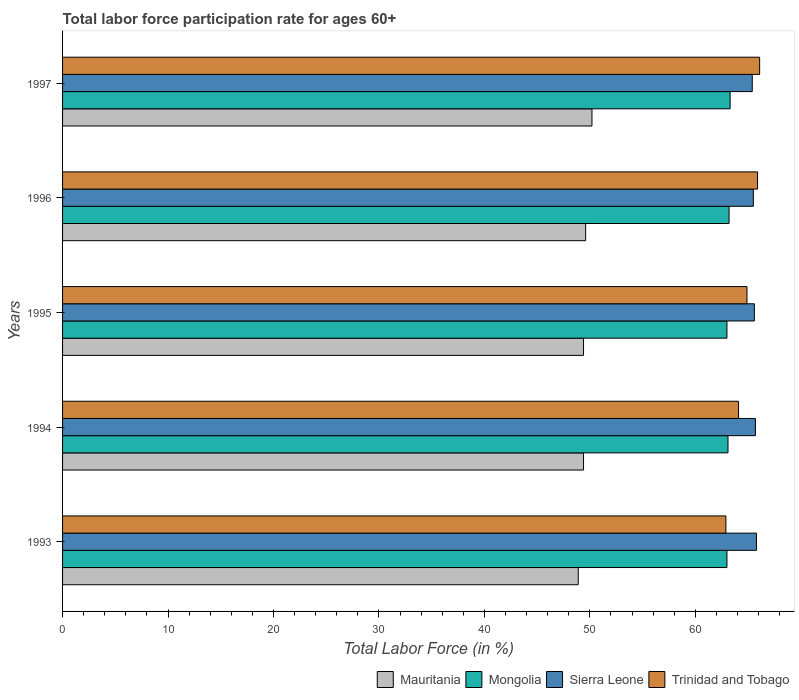How many different coloured bars are there?
Provide a succinct answer. 4. How many groups of bars are there?
Offer a terse response. 5. How many bars are there on the 1st tick from the top?
Provide a succinct answer. 4. How many bars are there on the 5th tick from the bottom?
Provide a succinct answer. 4. What is the label of the 2nd group of bars from the top?
Ensure brevity in your answer.  1996. What is the labor force participation rate in Mongolia in 1994?
Provide a short and direct response. 63.1. Across all years, what is the maximum labor force participation rate in Sierra Leone?
Give a very brief answer. 65.8. Across all years, what is the minimum labor force participation rate in Trinidad and Tobago?
Provide a short and direct response. 62.9. What is the total labor force participation rate in Mauritania in the graph?
Make the answer very short. 247.5. What is the difference between the labor force participation rate in Mauritania in 1993 and that in 1994?
Keep it short and to the point. -0.5. What is the difference between the labor force participation rate in Mongolia in 1994 and the labor force participation rate in Mauritania in 1993?
Provide a short and direct response. 14.2. What is the average labor force participation rate in Mauritania per year?
Offer a terse response. 49.5. In the year 1993, what is the difference between the labor force participation rate in Mongolia and labor force participation rate in Sierra Leone?
Make the answer very short. -2.8. In how many years, is the labor force participation rate in Sierra Leone greater than 20 %?
Keep it short and to the point. 5. What is the ratio of the labor force participation rate in Trinidad and Tobago in 1994 to that in 1997?
Offer a terse response. 0.97. Is the labor force participation rate in Mongolia in 1993 less than that in 1996?
Offer a very short reply. Yes. What is the difference between the highest and the second highest labor force participation rate in Trinidad and Tobago?
Keep it short and to the point. 0.2. What is the difference between the highest and the lowest labor force participation rate in Trinidad and Tobago?
Provide a short and direct response. 3.2. What does the 2nd bar from the top in 1997 represents?
Keep it short and to the point. Sierra Leone. What does the 2nd bar from the bottom in 1994 represents?
Provide a succinct answer. Mongolia. Are all the bars in the graph horizontal?
Make the answer very short. Yes. What is the difference between two consecutive major ticks on the X-axis?
Keep it short and to the point. 10. Are the values on the major ticks of X-axis written in scientific E-notation?
Give a very brief answer. No. Does the graph contain any zero values?
Your answer should be compact. No. What is the title of the graph?
Provide a succinct answer. Total labor force participation rate for ages 60+. What is the label or title of the X-axis?
Your response must be concise. Total Labor Force (in %). What is the Total Labor Force (in %) of Mauritania in 1993?
Offer a very short reply. 48.9. What is the Total Labor Force (in %) of Mongolia in 1993?
Your response must be concise. 63. What is the Total Labor Force (in %) of Sierra Leone in 1993?
Offer a terse response. 65.8. What is the Total Labor Force (in %) of Trinidad and Tobago in 1993?
Give a very brief answer. 62.9. What is the Total Labor Force (in %) of Mauritania in 1994?
Ensure brevity in your answer.  49.4. What is the Total Labor Force (in %) in Mongolia in 1994?
Offer a very short reply. 63.1. What is the Total Labor Force (in %) in Sierra Leone in 1994?
Ensure brevity in your answer.  65.7. What is the Total Labor Force (in %) of Trinidad and Tobago in 1994?
Provide a short and direct response. 64.1. What is the Total Labor Force (in %) of Mauritania in 1995?
Your answer should be compact. 49.4. What is the Total Labor Force (in %) of Mongolia in 1995?
Offer a terse response. 63. What is the Total Labor Force (in %) in Sierra Leone in 1995?
Provide a succinct answer. 65.6. What is the Total Labor Force (in %) of Trinidad and Tobago in 1995?
Make the answer very short. 64.9. What is the Total Labor Force (in %) of Mauritania in 1996?
Provide a short and direct response. 49.6. What is the Total Labor Force (in %) in Mongolia in 1996?
Make the answer very short. 63.2. What is the Total Labor Force (in %) in Sierra Leone in 1996?
Ensure brevity in your answer.  65.5. What is the Total Labor Force (in %) of Trinidad and Tobago in 1996?
Your response must be concise. 65.9. What is the Total Labor Force (in %) in Mauritania in 1997?
Keep it short and to the point. 50.2. What is the Total Labor Force (in %) in Mongolia in 1997?
Offer a very short reply. 63.3. What is the Total Labor Force (in %) of Sierra Leone in 1997?
Make the answer very short. 65.4. What is the Total Labor Force (in %) of Trinidad and Tobago in 1997?
Ensure brevity in your answer.  66.1. Across all years, what is the maximum Total Labor Force (in %) in Mauritania?
Offer a terse response. 50.2. Across all years, what is the maximum Total Labor Force (in %) in Mongolia?
Your answer should be very brief. 63.3. Across all years, what is the maximum Total Labor Force (in %) in Sierra Leone?
Your answer should be very brief. 65.8. Across all years, what is the maximum Total Labor Force (in %) in Trinidad and Tobago?
Make the answer very short. 66.1. Across all years, what is the minimum Total Labor Force (in %) of Mauritania?
Your answer should be very brief. 48.9. Across all years, what is the minimum Total Labor Force (in %) of Mongolia?
Keep it short and to the point. 63. Across all years, what is the minimum Total Labor Force (in %) in Sierra Leone?
Your answer should be very brief. 65.4. Across all years, what is the minimum Total Labor Force (in %) in Trinidad and Tobago?
Give a very brief answer. 62.9. What is the total Total Labor Force (in %) of Mauritania in the graph?
Your answer should be very brief. 247.5. What is the total Total Labor Force (in %) in Mongolia in the graph?
Provide a succinct answer. 315.6. What is the total Total Labor Force (in %) of Sierra Leone in the graph?
Your answer should be very brief. 328. What is the total Total Labor Force (in %) of Trinidad and Tobago in the graph?
Offer a terse response. 323.9. What is the difference between the Total Labor Force (in %) in Mauritania in 1993 and that in 1994?
Give a very brief answer. -0.5. What is the difference between the Total Labor Force (in %) in Trinidad and Tobago in 1993 and that in 1994?
Offer a very short reply. -1.2. What is the difference between the Total Labor Force (in %) of Mauritania in 1993 and that in 1995?
Provide a short and direct response. -0.5. What is the difference between the Total Labor Force (in %) in Mongolia in 1993 and that in 1995?
Ensure brevity in your answer.  0. What is the difference between the Total Labor Force (in %) in Sierra Leone in 1993 and that in 1995?
Give a very brief answer. 0.2. What is the difference between the Total Labor Force (in %) of Trinidad and Tobago in 1993 and that in 1995?
Your answer should be very brief. -2. What is the difference between the Total Labor Force (in %) in Mauritania in 1993 and that in 1996?
Offer a terse response. -0.7. What is the difference between the Total Labor Force (in %) in Trinidad and Tobago in 1993 and that in 1996?
Offer a terse response. -3. What is the difference between the Total Labor Force (in %) in Sierra Leone in 1994 and that in 1995?
Ensure brevity in your answer.  0.1. What is the difference between the Total Labor Force (in %) in Mauritania in 1994 and that in 1996?
Provide a short and direct response. -0.2. What is the difference between the Total Labor Force (in %) of Mongolia in 1994 and that in 1996?
Your answer should be compact. -0.1. What is the difference between the Total Labor Force (in %) in Mongolia in 1994 and that in 1997?
Provide a succinct answer. -0.2. What is the difference between the Total Labor Force (in %) of Sierra Leone in 1994 and that in 1997?
Your answer should be very brief. 0.3. What is the difference between the Total Labor Force (in %) in Mauritania in 1995 and that in 1996?
Your answer should be very brief. -0.2. What is the difference between the Total Labor Force (in %) of Trinidad and Tobago in 1995 and that in 1996?
Keep it short and to the point. -1. What is the difference between the Total Labor Force (in %) in Mongolia in 1995 and that in 1997?
Your response must be concise. -0.3. What is the difference between the Total Labor Force (in %) of Sierra Leone in 1995 and that in 1997?
Ensure brevity in your answer.  0.2. What is the difference between the Total Labor Force (in %) in Mongolia in 1996 and that in 1997?
Your response must be concise. -0.1. What is the difference between the Total Labor Force (in %) of Mauritania in 1993 and the Total Labor Force (in %) of Mongolia in 1994?
Your answer should be very brief. -14.2. What is the difference between the Total Labor Force (in %) in Mauritania in 1993 and the Total Labor Force (in %) in Sierra Leone in 1994?
Give a very brief answer. -16.8. What is the difference between the Total Labor Force (in %) in Mauritania in 1993 and the Total Labor Force (in %) in Trinidad and Tobago in 1994?
Make the answer very short. -15.2. What is the difference between the Total Labor Force (in %) in Mauritania in 1993 and the Total Labor Force (in %) in Mongolia in 1995?
Make the answer very short. -14.1. What is the difference between the Total Labor Force (in %) of Mauritania in 1993 and the Total Labor Force (in %) of Sierra Leone in 1995?
Provide a succinct answer. -16.7. What is the difference between the Total Labor Force (in %) in Mauritania in 1993 and the Total Labor Force (in %) in Trinidad and Tobago in 1995?
Your answer should be compact. -16. What is the difference between the Total Labor Force (in %) in Mongolia in 1993 and the Total Labor Force (in %) in Sierra Leone in 1995?
Make the answer very short. -2.6. What is the difference between the Total Labor Force (in %) of Mongolia in 1993 and the Total Labor Force (in %) of Trinidad and Tobago in 1995?
Give a very brief answer. -1.9. What is the difference between the Total Labor Force (in %) in Sierra Leone in 1993 and the Total Labor Force (in %) in Trinidad and Tobago in 1995?
Provide a short and direct response. 0.9. What is the difference between the Total Labor Force (in %) in Mauritania in 1993 and the Total Labor Force (in %) in Mongolia in 1996?
Give a very brief answer. -14.3. What is the difference between the Total Labor Force (in %) in Mauritania in 1993 and the Total Labor Force (in %) in Sierra Leone in 1996?
Make the answer very short. -16.6. What is the difference between the Total Labor Force (in %) in Mongolia in 1993 and the Total Labor Force (in %) in Sierra Leone in 1996?
Your response must be concise. -2.5. What is the difference between the Total Labor Force (in %) of Mongolia in 1993 and the Total Labor Force (in %) of Trinidad and Tobago in 1996?
Provide a short and direct response. -2.9. What is the difference between the Total Labor Force (in %) in Sierra Leone in 1993 and the Total Labor Force (in %) in Trinidad and Tobago in 1996?
Your answer should be very brief. -0.1. What is the difference between the Total Labor Force (in %) of Mauritania in 1993 and the Total Labor Force (in %) of Mongolia in 1997?
Make the answer very short. -14.4. What is the difference between the Total Labor Force (in %) in Mauritania in 1993 and the Total Labor Force (in %) in Sierra Leone in 1997?
Your response must be concise. -16.5. What is the difference between the Total Labor Force (in %) in Mauritania in 1993 and the Total Labor Force (in %) in Trinidad and Tobago in 1997?
Provide a succinct answer. -17.2. What is the difference between the Total Labor Force (in %) in Mongolia in 1993 and the Total Labor Force (in %) in Trinidad and Tobago in 1997?
Offer a terse response. -3.1. What is the difference between the Total Labor Force (in %) in Mauritania in 1994 and the Total Labor Force (in %) in Mongolia in 1995?
Provide a succinct answer. -13.6. What is the difference between the Total Labor Force (in %) in Mauritania in 1994 and the Total Labor Force (in %) in Sierra Leone in 1995?
Your answer should be very brief. -16.2. What is the difference between the Total Labor Force (in %) in Mauritania in 1994 and the Total Labor Force (in %) in Trinidad and Tobago in 1995?
Keep it short and to the point. -15.5. What is the difference between the Total Labor Force (in %) of Mongolia in 1994 and the Total Labor Force (in %) of Trinidad and Tobago in 1995?
Give a very brief answer. -1.8. What is the difference between the Total Labor Force (in %) in Sierra Leone in 1994 and the Total Labor Force (in %) in Trinidad and Tobago in 1995?
Make the answer very short. 0.8. What is the difference between the Total Labor Force (in %) of Mauritania in 1994 and the Total Labor Force (in %) of Sierra Leone in 1996?
Your answer should be very brief. -16.1. What is the difference between the Total Labor Force (in %) in Mauritania in 1994 and the Total Labor Force (in %) in Trinidad and Tobago in 1996?
Ensure brevity in your answer.  -16.5. What is the difference between the Total Labor Force (in %) in Mongolia in 1994 and the Total Labor Force (in %) in Sierra Leone in 1996?
Give a very brief answer. -2.4. What is the difference between the Total Labor Force (in %) of Mauritania in 1994 and the Total Labor Force (in %) of Sierra Leone in 1997?
Make the answer very short. -16. What is the difference between the Total Labor Force (in %) in Mauritania in 1994 and the Total Labor Force (in %) in Trinidad and Tobago in 1997?
Offer a terse response. -16.7. What is the difference between the Total Labor Force (in %) of Mongolia in 1994 and the Total Labor Force (in %) of Sierra Leone in 1997?
Offer a very short reply. -2.3. What is the difference between the Total Labor Force (in %) of Sierra Leone in 1994 and the Total Labor Force (in %) of Trinidad and Tobago in 1997?
Your answer should be very brief. -0.4. What is the difference between the Total Labor Force (in %) in Mauritania in 1995 and the Total Labor Force (in %) in Sierra Leone in 1996?
Provide a succinct answer. -16.1. What is the difference between the Total Labor Force (in %) of Mauritania in 1995 and the Total Labor Force (in %) of Trinidad and Tobago in 1996?
Ensure brevity in your answer.  -16.5. What is the difference between the Total Labor Force (in %) of Mongolia in 1995 and the Total Labor Force (in %) of Sierra Leone in 1996?
Your response must be concise. -2.5. What is the difference between the Total Labor Force (in %) of Sierra Leone in 1995 and the Total Labor Force (in %) of Trinidad and Tobago in 1996?
Offer a terse response. -0.3. What is the difference between the Total Labor Force (in %) in Mauritania in 1995 and the Total Labor Force (in %) in Mongolia in 1997?
Your answer should be very brief. -13.9. What is the difference between the Total Labor Force (in %) in Mauritania in 1995 and the Total Labor Force (in %) in Trinidad and Tobago in 1997?
Your answer should be compact. -16.7. What is the difference between the Total Labor Force (in %) of Mongolia in 1995 and the Total Labor Force (in %) of Trinidad and Tobago in 1997?
Your response must be concise. -3.1. What is the difference between the Total Labor Force (in %) in Sierra Leone in 1995 and the Total Labor Force (in %) in Trinidad and Tobago in 1997?
Offer a very short reply. -0.5. What is the difference between the Total Labor Force (in %) in Mauritania in 1996 and the Total Labor Force (in %) in Mongolia in 1997?
Your answer should be compact. -13.7. What is the difference between the Total Labor Force (in %) in Mauritania in 1996 and the Total Labor Force (in %) in Sierra Leone in 1997?
Offer a terse response. -15.8. What is the difference between the Total Labor Force (in %) of Mauritania in 1996 and the Total Labor Force (in %) of Trinidad and Tobago in 1997?
Offer a very short reply. -16.5. What is the difference between the Total Labor Force (in %) in Mongolia in 1996 and the Total Labor Force (in %) in Sierra Leone in 1997?
Provide a succinct answer. -2.2. What is the average Total Labor Force (in %) in Mauritania per year?
Provide a short and direct response. 49.5. What is the average Total Labor Force (in %) of Mongolia per year?
Offer a terse response. 63.12. What is the average Total Labor Force (in %) in Sierra Leone per year?
Make the answer very short. 65.6. What is the average Total Labor Force (in %) in Trinidad and Tobago per year?
Offer a terse response. 64.78. In the year 1993, what is the difference between the Total Labor Force (in %) of Mauritania and Total Labor Force (in %) of Mongolia?
Your answer should be compact. -14.1. In the year 1993, what is the difference between the Total Labor Force (in %) in Mauritania and Total Labor Force (in %) in Sierra Leone?
Offer a terse response. -16.9. In the year 1993, what is the difference between the Total Labor Force (in %) in Mongolia and Total Labor Force (in %) in Sierra Leone?
Provide a succinct answer. -2.8. In the year 1993, what is the difference between the Total Labor Force (in %) in Sierra Leone and Total Labor Force (in %) in Trinidad and Tobago?
Provide a short and direct response. 2.9. In the year 1994, what is the difference between the Total Labor Force (in %) in Mauritania and Total Labor Force (in %) in Mongolia?
Make the answer very short. -13.7. In the year 1994, what is the difference between the Total Labor Force (in %) of Mauritania and Total Labor Force (in %) of Sierra Leone?
Your response must be concise. -16.3. In the year 1994, what is the difference between the Total Labor Force (in %) of Mauritania and Total Labor Force (in %) of Trinidad and Tobago?
Make the answer very short. -14.7. In the year 1994, what is the difference between the Total Labor Force (in %) of Mongolia and Total Labor Force (in %) of Sierra Leone?
Offer a terse response. -2.6. In the year 1994, what is the difference between the Total Labor Force (in %) in Sierra Leone and Total Labor Force (in %) in Trinidad and Tobago?
Your answer should be compact. 1.6. In the year 1995, what is the difference between the Total Labor Force (in %) of Mauritania and Total Labor Force (in %) of Mongolia?
Ensure brevity in your answer.  -13.6. In the year 1995, what is the difference between the Total Labor Force (in %) in Mauritania and Total Labor Force (in %) in Sierra Leone?
Your answer should be compact. -16.2. In the year 1995, what is the difference between the Total Labor Force (in %) of Mauritania and Total Labor Force (in %) of Trinidad and Tobago?
Ensure brevity in your answer.  -15.5. In the year 1995, what is the difference between the Total Labor Force (in %) in Mongolia and Total Labor Force (in %) in Trinidad and Tobago?
Give a very brief answer. -1.9. In the year 1995, what is the difference between the Total Labor Force (in %) of Sierra Leone and Total Labor Force (in %) of Trinidad and Tobago?
Give a very brief answer. 0.7. In the year 1996, what is the difference between the Total Labor Force (in %) in Mauritania and Total Labor Force (in %) in Sierra Leone?
Make the answer very short. -15.9. In the year 1996, what is the difference between the Total Labor Force (in %) of Mauritania and Total Labor Force (in %) of Trinidad and Tobago?
Make the answer very short. -16.3. In the year 1996, what is the difference between the Total Labor Force (in %) of Mongolia and Total Labor Force (in %) of Sierra Leone?
Provide a succinct answer. -2.3. In the year 1996, what is the difference between the Total Labor Force (in %) of Mongolia and Total Labor Force (in %) of Trinidad and Tobago?
Ensure brevity in your answer.  -2.7. In the year 1996, what is the difference between the Total Labor Force (in %) in Sierra Leone and Total Labor Force (in %) in Trinidad and Tobago?
Make the answer very short. -0.4. In the year 1997, what is the difference between the Total Labor Force (in %) in Mauritania and Total Labor Force (in %) in Mongolia?
Your answer should be very brief. -13.1. In the year 1997, what is the difference between the Total Labor Force (in %) in Mauritania and Total Labor Force (in %) in Sierra Leone?
Your response must be concise. -15.2. In the year 1997, what is the difference between the Total Labor Force (in %) in Mauritania and Total Labor Force (in %) in Trinidad and Tobago?
Ensure brevity in your answer.  -15.9. In the year 1997, what is the difference between the Total Labor Force (in %) in Mongolia and Total Labor Force (in %) in Sierra Leone?
Make the answer very short. -2.1. In the year 1997, what is the difference between the Total Labor Force (in %) in Mongolia and Total Labor Force (in %) in Trinidad and Tobago?
Make the answer very short. -2.8. In the year 1997, what is the difference between the Total Labor Force (in %) of Sierra Leone and Total Labor Force (in %) of Trinidad and Tobago?
Your answer should be compact. -0.7. What is the ratio of the Total Labor Force (in %) of Mongolia in 1993 to that in 1994?
Keep it short and to the point. 1. What is the ratio of the Total Labor Force (in %) in Sierra Leone in 1993 to that in 1994?
Offer a terse response. 1. What is the ratio of the Total Labor Force (in %) of Trinidad and Tobago in 1993 to that in 1994?
Offer a terse response. 0.98. What is the ratio of the Total Labor Force (in %) in Mongolia in 1993 to that in 1995?
Ensure brevity in your answer.  1. What is the ratio of the Total Labor Force (in %) in Sierra Leone in 1993 to that in 1995?
Provide a short and direct response. 1. What is the ratio of the Total Labor Force (in %) of Trinidad and Tobago in 1993 to that in 1995?
Provide a short and direct response. 0.97. What is the ratio of the Total Labor Force (in %) in Mauritania in 1993 to that in 1996?
Offer a terse response. 0.99. What is the ratio of the Total Labor Force (in %) in Sierra Leone in 1993 to that in 1996?
Your response must be concise. 1. What is the ratio of the Total Labor Force (in %) in Trinidad and Tobago in 1993 to that in 1996?
Keep it short and to the point. 0.95. What is the ratio of the Total Labor Force (in %) in Mauritania in 1993 to that in 1997?
Keep it short and to the point. 0.97. What is the ratio of the Total Labor Force (in %) in Mongolia in 1993 to that in 1997?
Provide a short and direct response. 1. What is the ratio of the Total Labor Force (in %) in Sierra Leone in 1993 to that in 1997?
Your response must be concise. 1.01. What is the ratio of the Total Labor Force (in %) of Trinidad and Tobago in 1993 to that in 1997?
Give a very brief answer. 0.95. What is the ratio of the Total Labor Force (in %) of Mauritania in 1994 to that in 1995?
Provide a succinct answer. 1. What is the ratio of the Total Labor Force (in %) of Mongolia in 1994 to that in 1995?
Your answer should be very brief. 1. What is the ratio of the Total Labor Force (in %) of Sierra Leone in 1994 to that in 1995?
Offer a very short reply. 1. What is the ratio of the Total Labor Force (in %) of Mauritania in 1994 to that in 1996?
Keep it short and to the point. 1. What is the ratio of the Total Labor Force (in %) in Trinidad and Tobago in 1994 to that in 1996?
Make the answer very short. 0.97. What is the ratio of the Total Labor Force (in %) of Mauritania in 1994 to that in 1997?
Your answer should be very brief. 0.98. What is the ratio of the Total Labor Force (in %) in Trinidad and Tobago in 1994 to that in 1997?
Provide a succinct answer. 0.97. What is the ratio of the Total Labor Force (in %) of Mauritania in 1995 to that in 1996?
Ensure brevity in your answer.  1. What is the ratio of the Total Labor Force (in %) of Sierra Leone in 1995 to that in 1996?
Ensure brevity in your answer.  1. What is the ratio of the Total Labor Force (in %) of Trinidad and Tobago in 1995 to that in 1996?
Give a very brief answer. 0.98. What is the ratio of the Total Labor Force (in %) of Mauritania in 1995 to that in 1997?
Provide a succinct answer. 0.98. What is the ratio of the Total Labor Force (in %) in Trinidad and Tobago in 1995 to that in 1997?
Your answer should be compact. 0.98. What is the ratio of the Total Labor Force (in %) of Mauritania in 1996 to that in 1997?
Make the answer very short. 0.99. What is the ratio of the Total Labor Force (in %) of Sierra Leone in 1996 to that in 1997?
Your answer should be very brief. 1. What is the ratio of the Total Labor Force (in %) in Trinidad and Tobago in 1996 to that in 1997?
Your answer should be very brief. 1. What is the difference between the highest and the second highest Total Labor Force (in %) of Sierra Leone?
Offer a terse response. 0.1. What is the difference between the highest and the second highest Total Labor Force (in %) of Trinidad and Tobago?
Offer a very short reply. 0.2. What is the difference between the highest and the lowest Total Labor Force (in %) in Mauritania?
Offer a very short reply. 1.3. What is the difference between the highest and the lowest Total Labor Force (in %) in Mongolia?
Give a very brief answer. 0.3. What is the difference between the highest and the lowest Total Labor Force (in %) of Sierra Leone?
Keep it short and to the point. 0.4. What is the difference between the highest and the lowest Total Labor Force (in %) in Trinidad and Tobago?
Offer a very short reply. 3.2. 